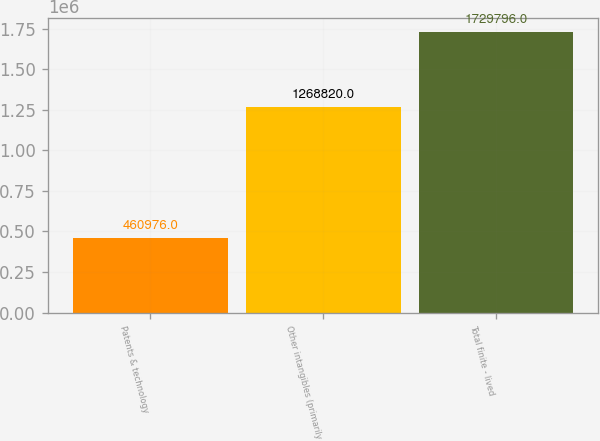Convert chart to OTSL. <chart><loc_0><loc_0><loc_500><loc_500><bar_chart><fcel>Patents & technology<fcel>Other intangibles (primarily<fcel>Total finite - lived<nl><fcel>460976<fcel>1.26882e+06<fcel>1.7298e+06<nl></chart> 